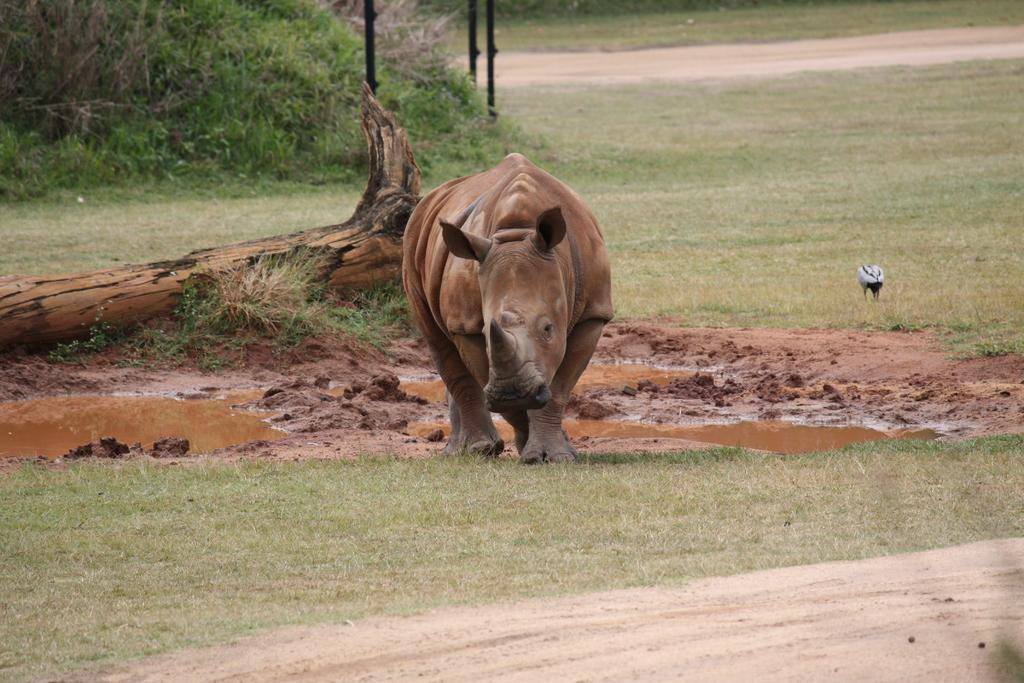What type of animal is in the image? There is an animal in the image, but the specific type cannot be determined from the provided facts. What other living creature is in the image? There is a bird in the image. Where is the bird located in the image? The bird is on the ground. What can be seen in the background of the image? Water, mud, a wooden log, a planter, and poles are visible in the background of the image. What type of doctor is attending to the bird in the image? There is no doctor present in the image, and the bird is not receiving any medical attention. What type of ball is being used by the animal in the image? There is no ball present in the image, and the animal is not interacting with any ball. 